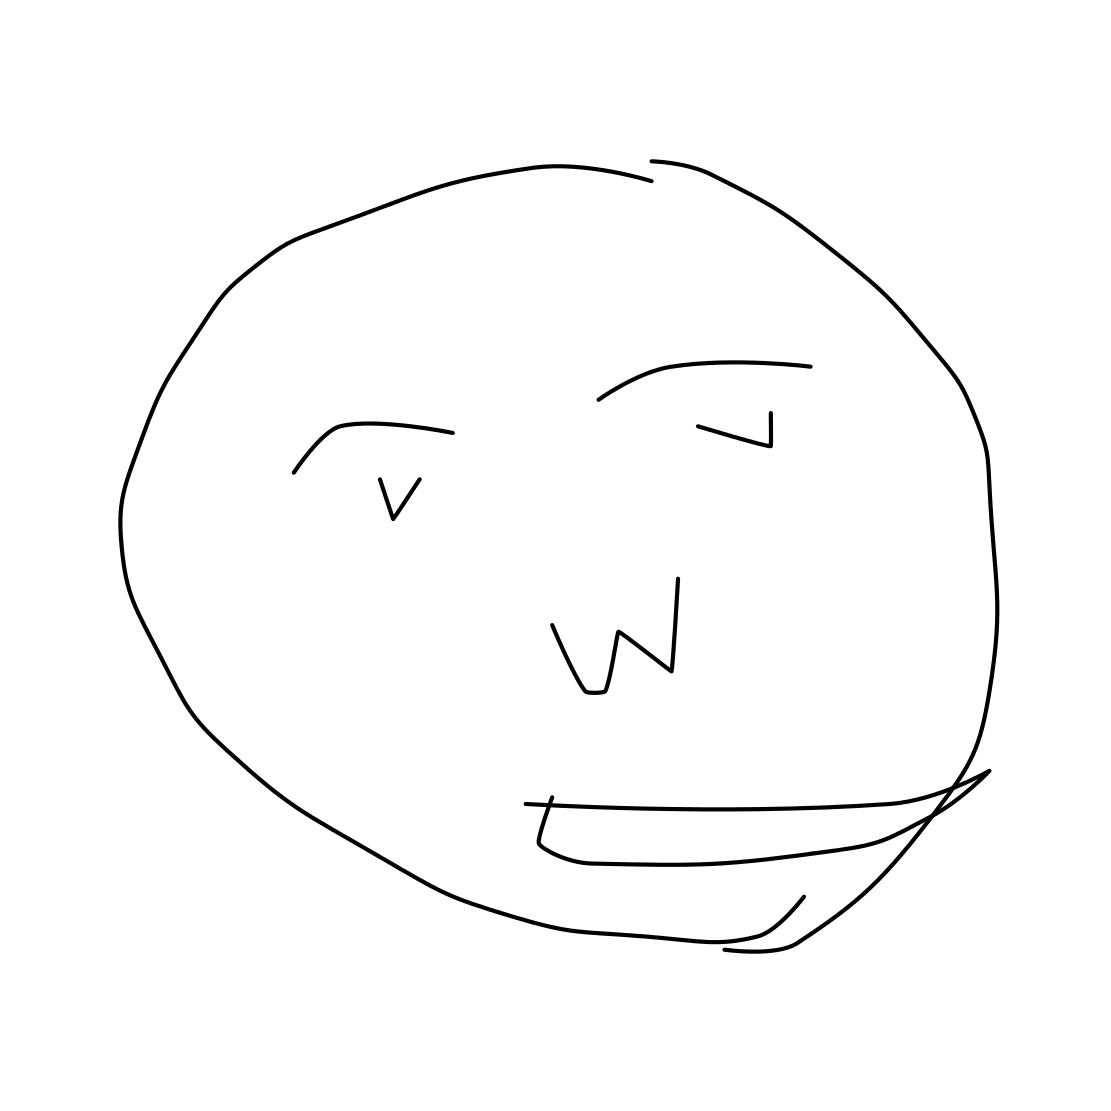What could be the significance of such a minimalist style in depicting faces? The minimalist style used to depict this face can suggest a focus on conveying emotions and expressions in a straightforward, clear manner without the distraction of intricate details. It's effective in quickly communicating basic human emotions, usable in various educational, artistic, or therapeutic contexts. 